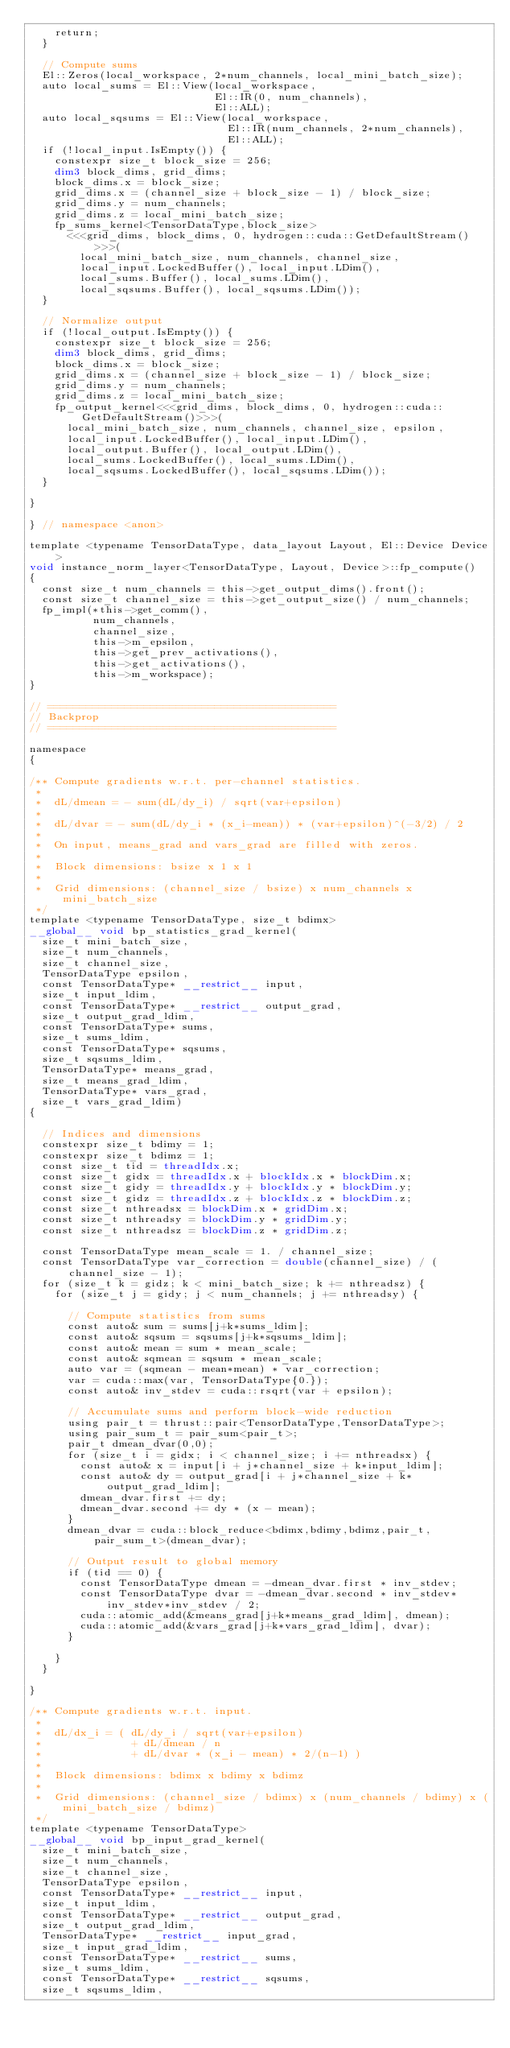<code> <loc_0><loc_0><loc_500><loc_500><_Cuda_>    return;
  }

  // Compute sums
  El::Zeros(local_workspace, 2*num_channels, local_mini_batch_size);
  auto local_sums = El::View(local_workspace,
                             El::IR(0, num_channels),
                             El::ALL);
  auto local_sqsums = El::View(local_workspace,
                               El::IR(num_channels, 2*num_channels),
                               El::ALL);
  if (!local_input.IsEmpty()) {
    constexpr size_t block_size = 256;
    dim3 block_dims, grid_dims;
    block_dims.x = block_size;
    grid_dims.x = (channel_size + block_size - 1) / block_size;
    grid_dims.y = num_channels;
    grid_dims.z = local_mini_batch_size;
    fp_sums_kernel<TensorDataType,block_size>
      <<<grid_dims, block_dims, 0, hydrogen::cuda::GetDefaultStream()>>>(
        local_mini_batch_size, num_channels, channel_size,
        local_input.LockedBuffer(), local_input.LDim(),
        local_sums.Buffer(), local_sums.LDim(),
        local_sqsums.Buffer(), local_sqsums.LDim());
  }

  // Normalize output
  if (!local_output.IsEmpty()) {
    constexpr size_t block_size = 256;
    dim3 block_dims, grid_dims;
    block_dims.x = block_size;
    grid_dims.x = (channel_size + block_size - 1) / block_size;
    grid_dims.y = num_channels;
    grid_dims.z = local_mini_batch_size;
    fp_output_kernel<<<grid_dims, block_dims, 0, hydrogen::cuda::GetDefaultStream()>>>(
      local_mini_batch_size, num_channels, channel_size, epsilon,
      local_input.LockedBuffer(), local_input.LDim(),
      local_output.Buffer(), local_output.LDim(),
      local_sums.LockedBuffer(), local_sums.LDim(),
      local_sqsums.LockedBuffer(), local_sqsums.LDim());
  }

}

} // namespace <anon>

template <typename TensorDataType, data_layout Layout, El::Device Device>
void instance_norm_layer<TensorDataType, Layout, Device>::fp_compute()
{
  const size_t num_channels = this->get_output_dims().front();
  const size_t channel_size = this->get_output_size() / num_channels;
  fp_impl(*this->get_comm(),
          num_channels,
          channel_size,
          this->m_epsilon,
          this->get_prev_activations(),
          this->get_activations(),
          this->m_workspace);
}

// =============================================
// Backprop
// =============================================

namespace
{

/** Compute gradients w.r.t. per-channel statistics.
 *
 *  dL/dmean = - sum(dL/dy_i) / sqrt(var+epsilon)
 *
 *  dL/dvar = - sum(dL/dy_i * (x_i-mean)) * (var+epsilon)^(-3/2) / 2
 *
 *  On input, means_grad and vars_grad are filled with zeros.
 *
 *  Block dimensions: bsize x 1 x 1
 *
 *  Grid dimensions: (channel_size / bsize) x num_channels x mini_batch_size
 */
template <typename TensorDataType, size_t bdimx>
__global__ void bp_statistics_grad_kernel(
  size_t mini_batch_size,
  size_t num_channels,
  size_t channel_size,
  TensorDataType epsilon,
  const TensorDataType* __restrict__ input,
  size_t input_ldim,
  const TensorDataType* __restrict__ output_grad,
  size_t output_grad_ldim,
  const TensorDataType* sums,
  size_t sums_ldim,
  const TensorDataType* sqsums,
  size_t sqsums_ldim,
  TensorDataType* means_grad,
  size_t means_grad_ldim,
  TensorDataType* vars_grad,
  size_t vars_grad_ldim)
{

  // Indices and dimensions
  constexpr size_t bdimy = 1;
  constexpr size_t bdimz = 1;
  const size_t tid = threadIdx.x;
  const size_t gidx = threadIdx.x + blockIdx.x * blockDim.x;
  const size_t gidy = threadIdx.y + blockIdx.y * blockDim.y;
  const size_t gidz = threadIdx.z + blockIdx.z * blockDim.z;
  const size_t nthreadsx = blockDim.x * gridDim.x;
  const size_t nthreadsy = blockDim.y * gridDim.y;
  const size_t nthreadsz = blockDim.z * gridDim.z;

  const TensorDataType mean_scale = 1. / channel_size;
  const TensorDataType var_correction = double(channel_size) / (channel_size - 1);
  for (size_t k = gidz; k < mini_batch_size; k += nthreadsz) {
    for (size_t j = gidy; j < num_channels; j += nthreadsy) {

      // Compute statistics from sums
      const auto& sum = sums[j+k*sums_ldim];
      const auto& sqsum = sqsums[j+k*sqsums_ldim];
      const auto& mean = sum * mean_scale;
      const auto& sqmean = sqsum * mean_scale;
      auto var = (sqmean - mean*mean) * var_correction;
      var = cuda::max(var, TensorDataType{0.});
      const auto& inv_stdev = cuda::rsqrt(var + epsilon);

      // Accumulate sums and perform block-wide reduction
      using pair_t = thrust::pair<TensorDataType,TensorDataType>;
      using pair_sum_t = pair_sum<pair_t>;
      pair_t dmean_dvar(0,0);
      for (size_t i = gidx; i < channel_size; i += nthreadsx) {
        const auto& x = input[i + j*channel_size + k*input_ldim];
        const auto& dy = output_grad[i + j*channel_size + k*output_grad_ldim];
        dmean_dvar.first += dy;
        dmean_dvar.second += dy * (x - mean);
      }
      dmean_dvar = cuda::block_reduce<bdimx,bdimy,bdimz,pair_t,pair_sum_t>(dmean_dvar);

      // Output result to global memory
      if (tid == 0) {
        const TensorDataType dmean = -dmean_dvar.first * inv_stdev;
        const TensorDataType dvar = -dmean_dvar.second * inv_stdev*inv_stdev*inv_stdev / 2;
        cuda::atomic_add(&means_grad[j+k*means_grad_ldim], dmean);
        cuda::atomic_add(&vars_grad[j+k*vars_grad_ldim], dvar);
      }

    }
  }

}

/** Compute gradients w.r.t. input.
 *
 *  dL/dx_i = ( dL/dy_i / sqrt(var+epsilon)
 *              + dL/dmean / n
 *              + dL/dvar * (x_i - mean) * 2/(n-1) )
 *
 *  Block dimensions: bdimx x bdimy x bdimz
 *
 *  Grid dimensions: (channel_size / bdimx) x (num_channels / bdimy) x (mini_batch_size / bdimz)
 */
template <typename TensorDataType>
__global__ void bp_input_grad_kernel(
  size_t mini_batch_size,
  size_t num_channels,
  size_t channel_size,
  TensorDataType epsilon,
  const TensorDataType* __restrict__ input,
  size_t input_ldim,
  const TensorDataType* __restrict__ output_grad,
  size_t output_grad_ldim,
  TensorDataType* __restrict__ input_grad,
  size_t input_grad_ldim,
  const TensorDataType* __restrict__ sums,
  size_t sums_ldim,
  const TensorDataType* __restrict__ sqsums,
  size_t sqsums_ldim,</code> 